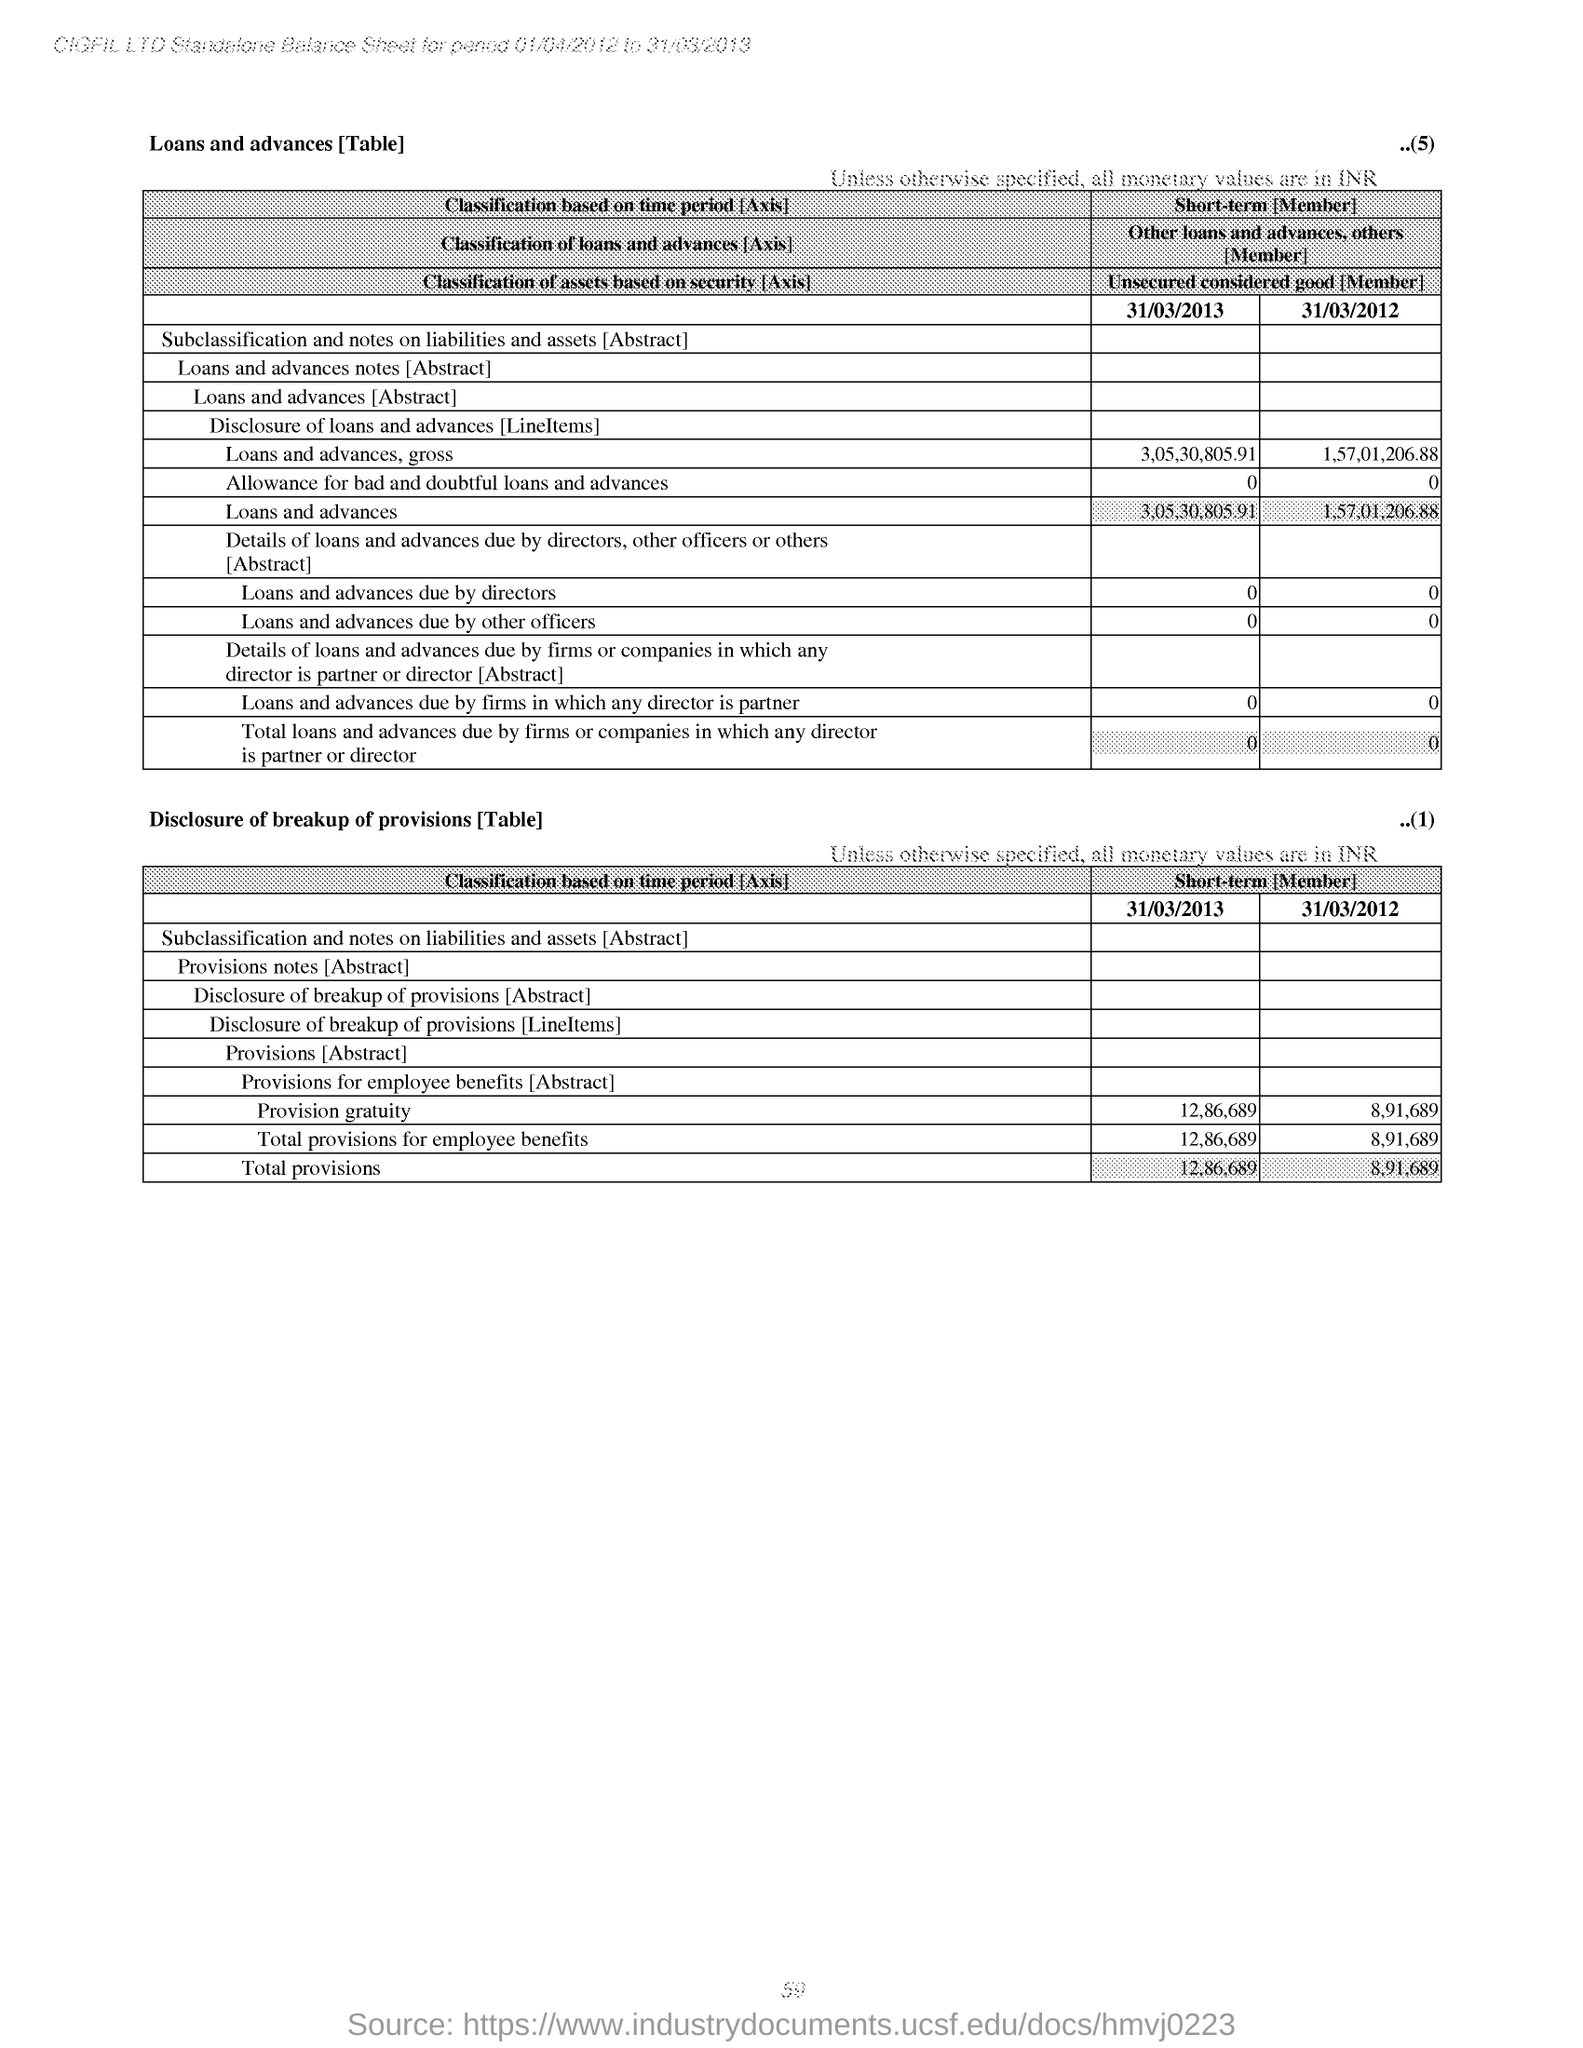Mention a couple of crucial points in this snapshot. What is the amount of loans and advances due by directors as of March 31, 2013? The total provisions for March 31, 2013, were 12,86,689. The total provisions for employee benefits as of March 31, 2012, were 8,91,689. On March 31st, 2012, the total amount of loans and advances was 1,57,01,206.88. The total provisions for March 31, 2012, were 8,91,689. 